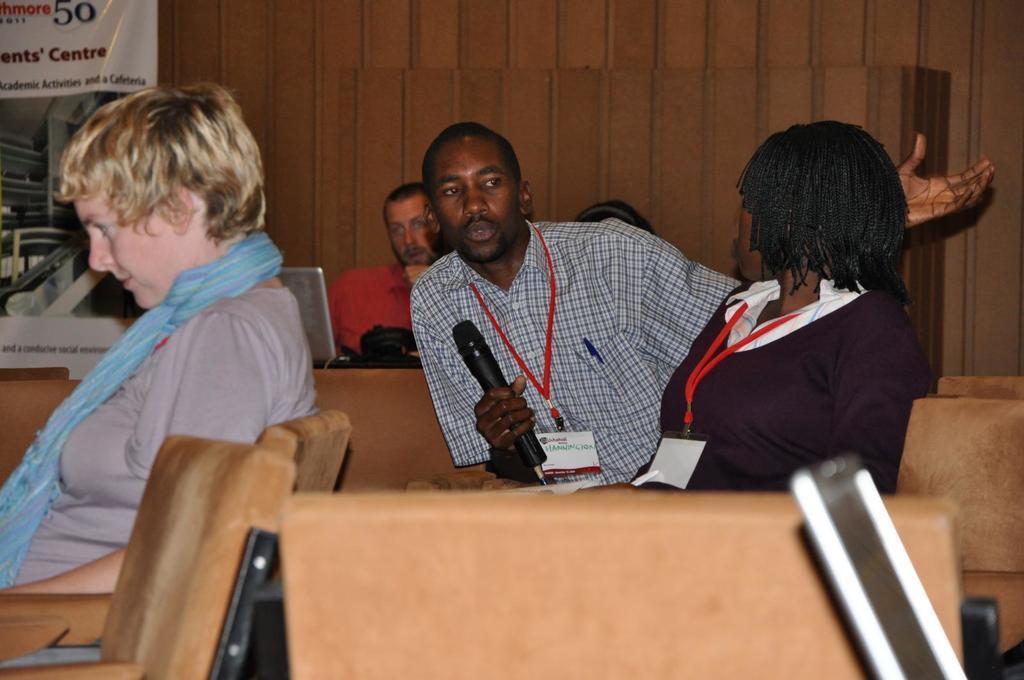Describe this image in one or two sentences. In this image i can see group of people sitting on a chair ,the women sitting here holding a microphone and wearing a badge at the back ground i can see a banner and a wooden wall. 